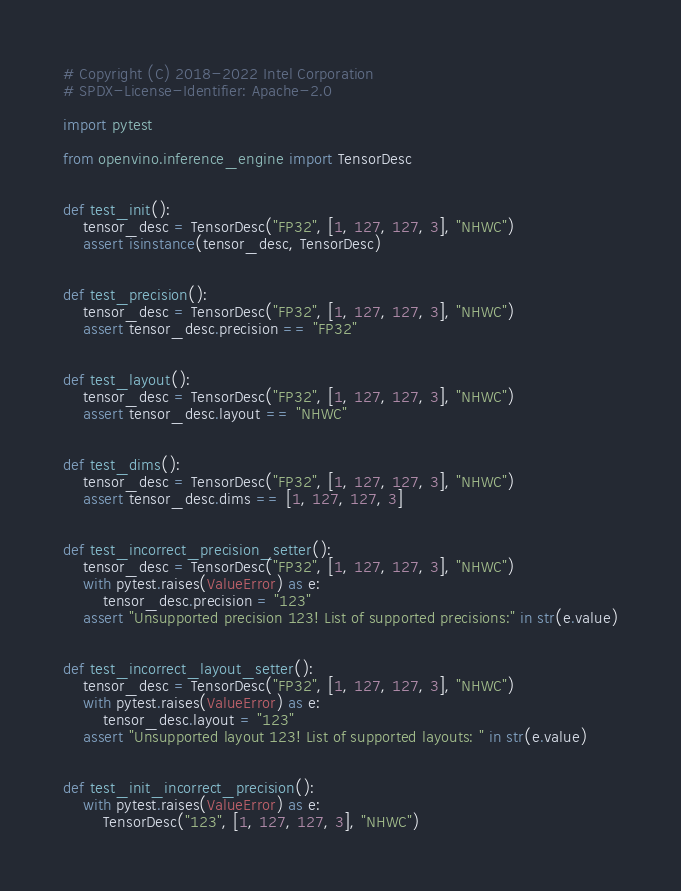<code> <loc_0><loc_0><loc_500><loc_500><_Python_># Copyright (C) 2018-2022 Intel Corporation
# SPDX-License-Identifier: Apache-2.0

import pytest

from openvino.inference_engine import TensorDesc


def test_init():
    tensor_desc = TensorDesc("FP32", [1, 127, 127, 3], "NHWC")
    assert isinstance(tensor_desc, TensorDesc)


def test_precision():
    tensor_desc = TensorDesc("FP32", [1, 127, 127, 3], "NHWC")
    assert tensor_desc.precision == "FP32"


def test_layout():
    tensor_desc = TensorDesc("FP32", [1, 127, 127, 3], "NHWC")
    assert tensor_desc.layout == "NHWC"


def test_dims():
    tensor_desc = TensorDesc("FP32", [1, 127, 127, 3], "NHWC")
    assert tensor_desc.dims == [1, 127, 127, 3]


def test_incorrect_precision_setter():
    tensor_desc = TensorDesc("FP32", [1, 127, 127, 3], "NHWC")
    with pytest.raises(ValueError) as e:
        tensor_desc.precision = "123"
    assert "Unsupported precision 123! List of supported precisions:" in str(e.value)


def test_incorrect_layout_setter():
    tensor_desc = TensorDesc("FP32", [1, 127, 127, 3], "NHWC")
    with pytest.raises(ValueError) as e:
        tensor_desc.layout = "123"
    assert "Unsupported layout 123! List of supported layouts: " in str(e.value)


def test_init_incorrect_precision():
    with pytest.raises(ValueError) as e:
        TensorDesc("123", [1, 127, 127, 3], "NHWC")</code> 